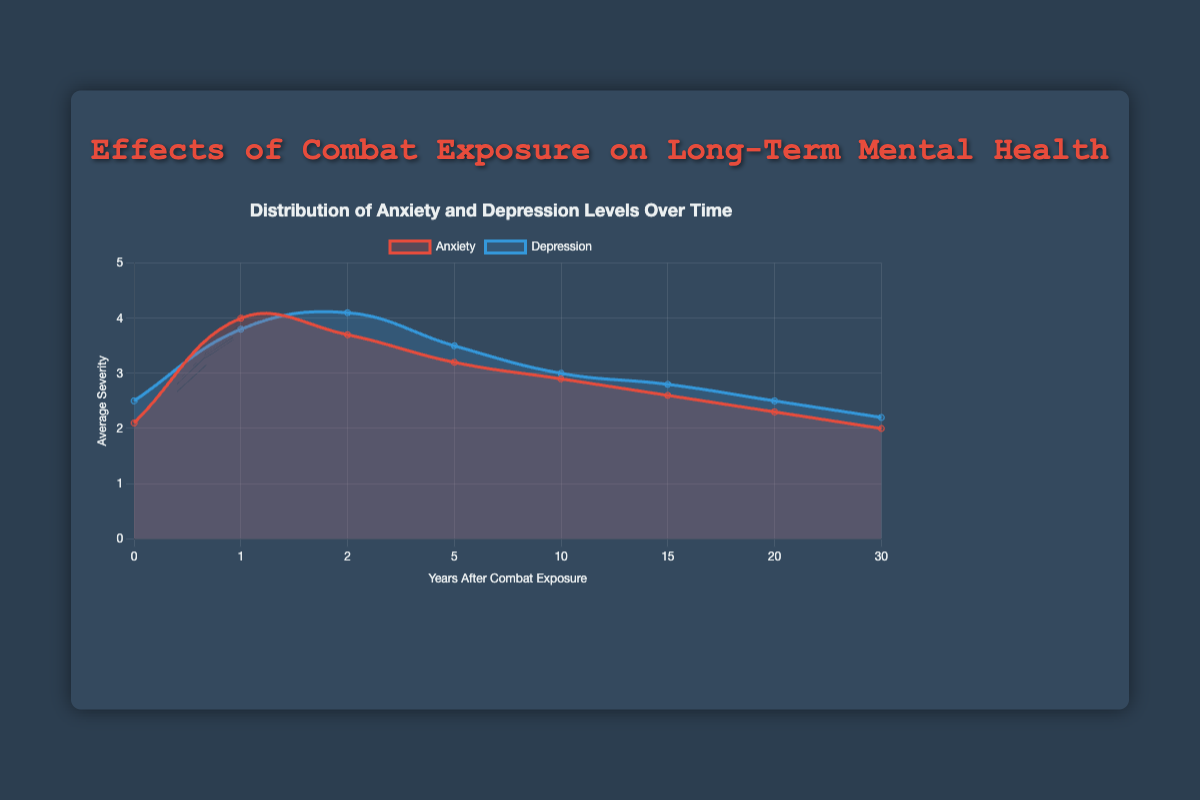What is the overall trend observed in the levels of anxiety over the 30-year period after combat exposure? The trend shows that anxiety levels increase initially, peaking at around 1 year, and then gradually decrease over the 30-year period.
Answer: Decreasing Which category, anxiety or depression, has a higher average severity in the first year after combat exposure? In the first year, the average severity of anxiety is 4.0, whereas the average severity of depression is 3.8. So, anxiety has a higher average severity.
Answer: Anxiety How does the average severity of depression change from year 2 to year 5 after combat exposure? The average severity of depression decreases from 4.1 in year 2 to 3.5 in year 5.
Answer: Decreases Compare the average severity levels of anxiety and depression 10 years after combat exposure. Which has a higher average severity and by how much? At 10 years, the average severity of anxiety is 2.9, while depression is 3.0. Depression has a higher severity by 0.1.
Answer: Depression, by 0.1 What is the average severity of anxiety 30 years after combat exposure, and what is its standard deviation? The average severity of anxiety 30 years after combat exposure is 2.0, with a standard deviation of 0.2.
Answer: 2.0 and 0.2 Between which periods does anxiety show the steepest decline in average severity? Anxiety shows the steepest decline between 1 year (severity 4.0) and 2 years (severity 3.7). This is a decline of 0.3 units.
Answer: Between 1 and 2 years Compare the initial average severities of anxiety and depression and determine the difference. Initially, the average severity of anxiety is 2.1, and depression is 2.5. The difference is 2.5 - 2.1 = 0.4.
Answer: 0.4 What visual attributes distinguish the anxiety data from the depression data in the figure? The anxiety line is red with a solid fill of lighter red, whereas the depression line is blue with a solid fill of lighter blue.
Answer: Color and fill How much does the average severity of anxiety decreased from its peak at 1 year to 30 years after combat exposure? The peak average severity of anxiety is 4.0 at 1 year, and it decreases to 2.0 at 30 years, a drop of 4.0 - 2.0 = 2.0 units.
Answer: 2.0 units At what time points do the average severity levels of depression show an increase, and what are the values at those points? Depression severity increases from year 1 (3.8) to year 2 (4.1).
Answer: From 3.8 to 4.1 